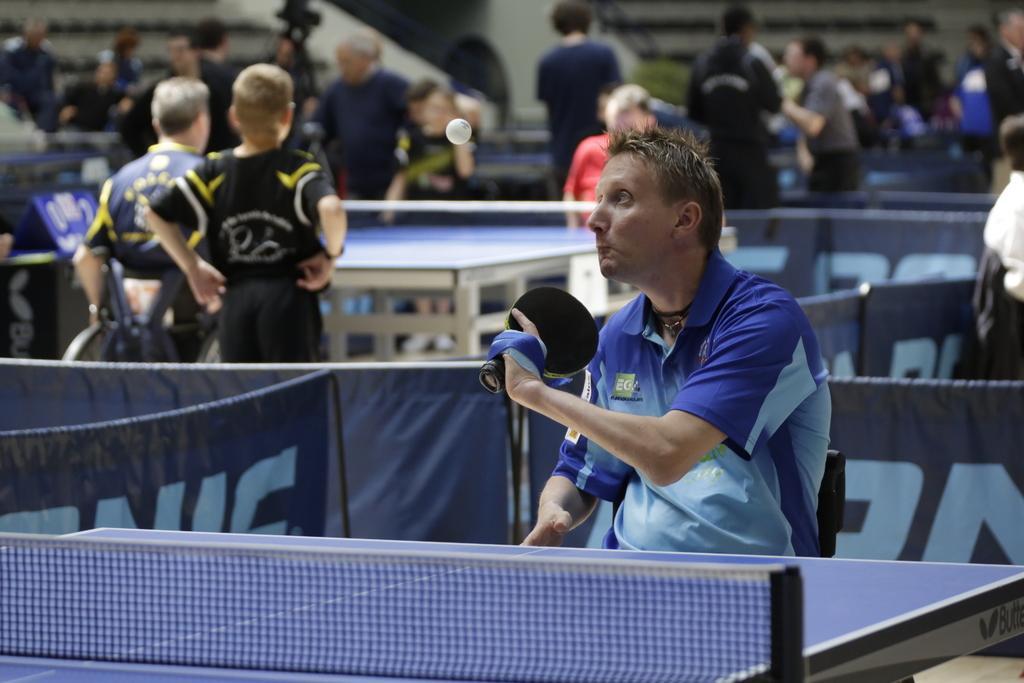Please provide a concise description of this image. In this image I see a man who is holding a bat and there is a table in front of him. In the background I see lot of people and there is a table over here too. 